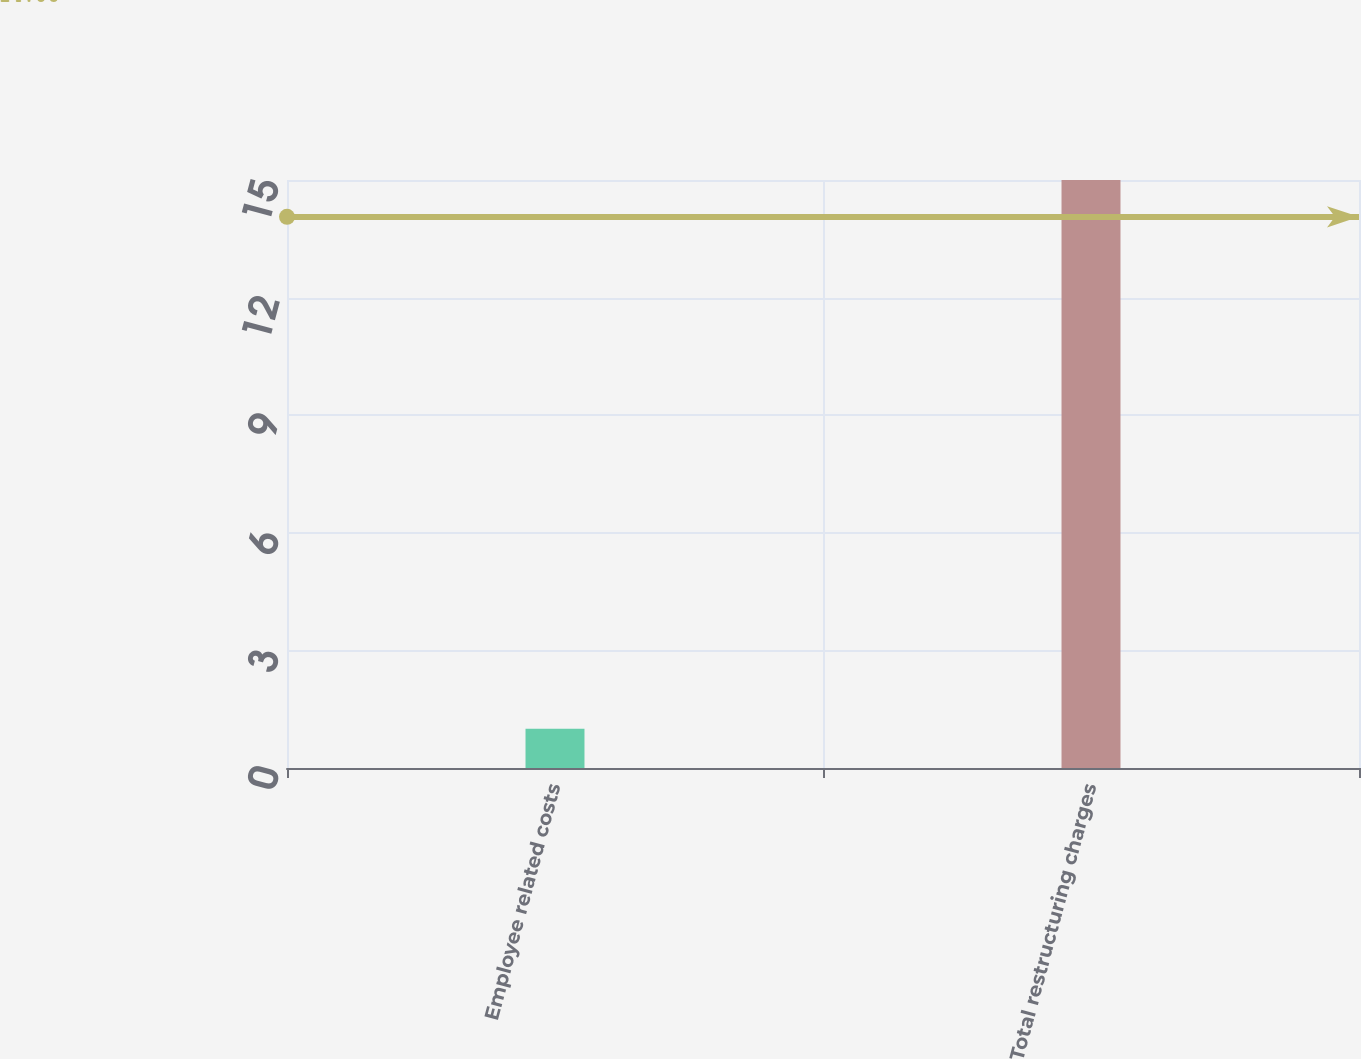Convert chart to OTSL. <chart><loc_0><loc_0><loc_500><loc_500><bar_chart><fcel>Employee related costs<fcel>Total restructuring charges<nl><fcel>1<fcel>15<nl></chart> 